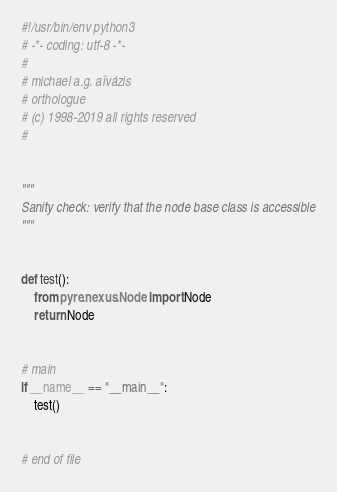Convert code to text. <code><loc_0><loc_0><loc_500><loc_500><_Python_>#!/usr/bin/env python3
# -*- coding: utf-8 -*-
#
# michael a.g. aïvázis
# orthologue
# (c) 1998-2019 all rights reserved
#


"""
Sanity check: verify that the node base class is accessible
"""


def test():
    from pyre.nexus.Node import Node
    return Node


# main
if __name__ == "__main__":
    test()


# end of file
</code> 